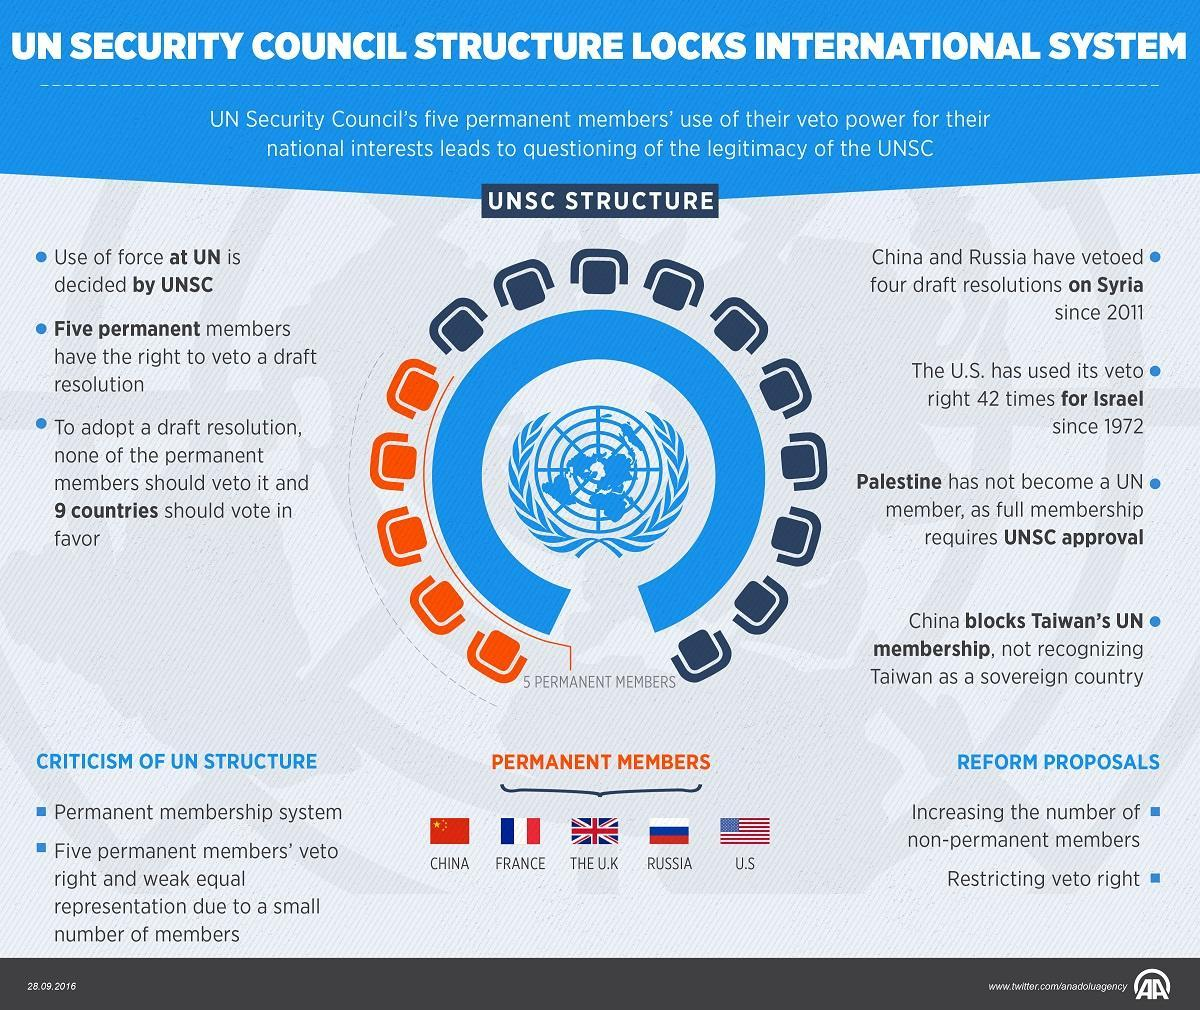How many permanent members are there in the UN?
Answer the question with a short phrase. 5 Which countries have used their veto power for their national interests? China, Russia, U.S. How many seats are reserved for non-permanent members ? 10 